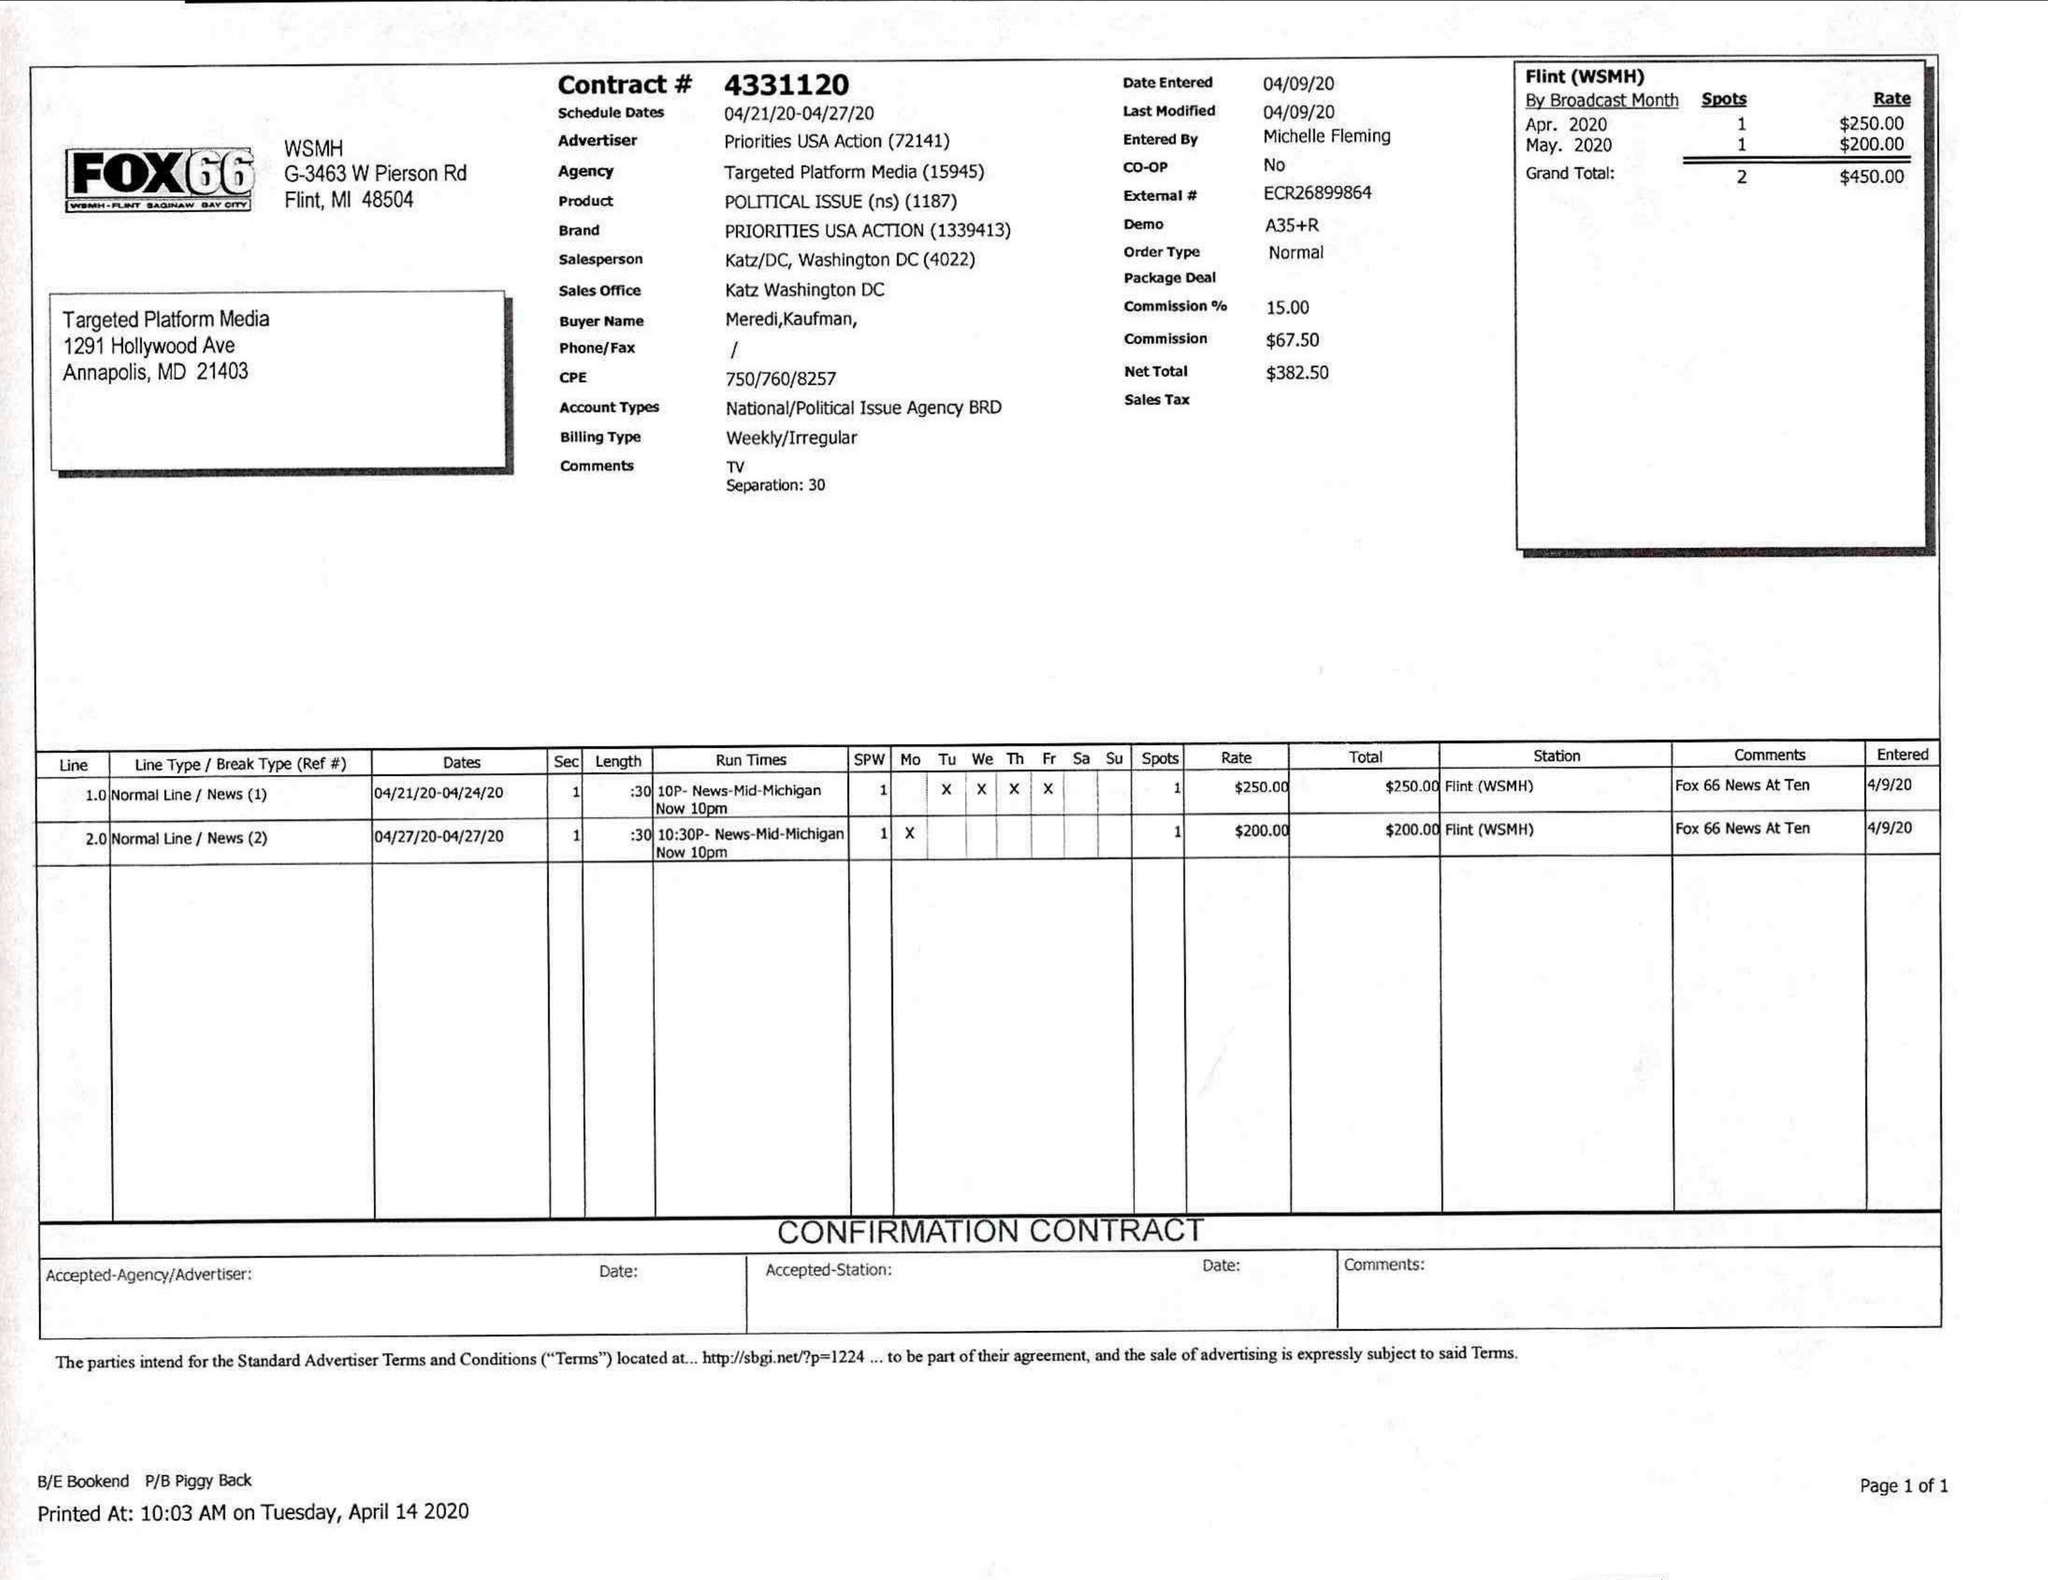What is the value for the flight_from?
Answer the question using a single word or phrase. 04/21/20 